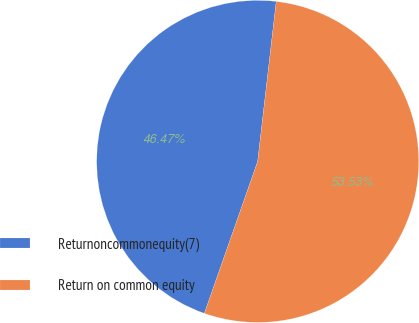Convert chart. <chart><loc_0><loc_0><loc_500><loc_500><pie_chart><fcel>Returnoncommonequity(7)<fcel>Return on common equity<nl><fcel>46.47%<fcel>53.53%<nl></chart> 